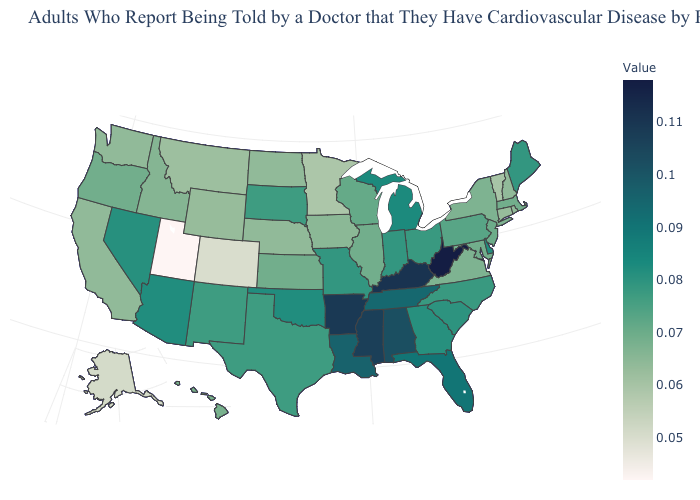Which states have the lowest value in the USA?
Keep it brief. Utah. Is the legend a continuous bar?
Answer briefly. Yes. Which states have the lowest value in the USA?
Keep it brief. Utah. Among the states that border New Jersey , does New York have the lowest value?
Keep it brief. Yes. Does the map have missing data?
Quick response, please. No. 